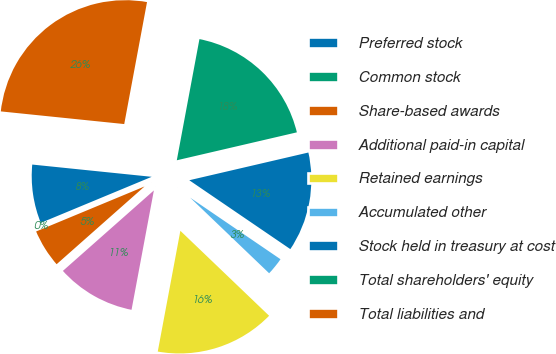Convert chart to OTSL. <chart><loc_0><loc_0><loc_500><loc_500><pie_chart><fcel>Preferred stock<fcel>Common stock<fcel>Share-based awards<fcel>Additional paid-in capital<fcel>Retained earnings<fcel>Accumulated other<fcel>Stock held in treasury at cost<fcel>Total shareholders' equity<fcel>Total liabilities and<nl><fcel>7.89%<fcel>0.0%<fcel>5.26%<fcel>10.53%<fcel>15.79%<fcel>2.63%<fcel>13.16%<fcel>18.42%<fcel>26.31%<nl></chart> 